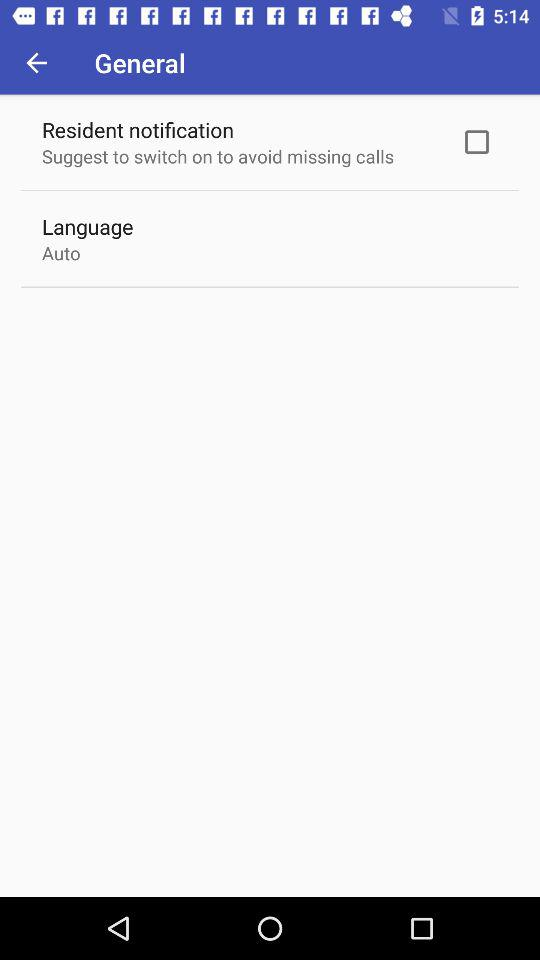What language has been mentioned? The mentioned language is auto. 